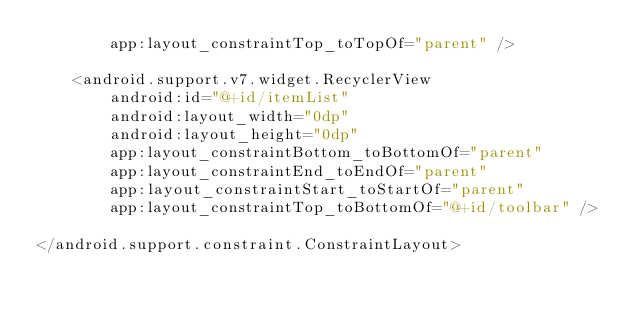<code> <loc_0><loc_0><loc_500><loc_500><_XML_>        app:layout_constraintTop_toTopOf="parent" />

    <android.support.v7.widget.RecyclerView
        android:id="@+id/itemList"
        android:layout_width="0dp"
        android:layout_height="0dp"
        app:layout_constraintBottom_toBottomOf="parent"
        app:layout_constraintEnd_toEndOf="parent"
        app:layout_constraintStart_toStartOf="parent"
        app:layout_constraintTop_toBottomOf="@+id/toolbar" />

</android.support.constraint.ConstraintLayout></code> 